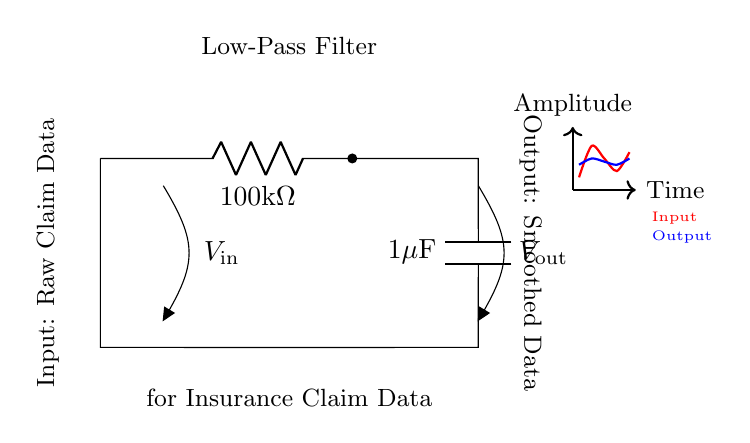What type of filter is represented in the circuit? The circuit is a low-pass filter, which allows low-frequency signals to pass while attenuating high-frequency signals.
Answer: low-pass filter What is the resistance value used in the circuit? The resistor shown in the circuit is labeled as 100 kilohms, representing its resistance value.
Answer: 100 kilohms What is the capacitance value in the filter? The capacitor in the circuit is labeled as 1 microfarad, which indicates its capacitance value.
Answer: 1 microfarad What does the output voltage represent in this circuit? The output voltage represents the smoothed data derived from the raw claim data input, which is affected by the low-pass filtering process.
Answer: Smoothed data How does the low-pass filter affect fluctuations in the input data? The low-pass filter attenuates rapid fluctuations in the input data, allowing only gradual changes to appear in the output, thereby smoothing the data trend.
Answer: Attenuates fluctuations What is the purpose of using a low-pass filter in insurance claim data analysis? The purpose is to reduce noise and smooth out data fluctuations, enabling better trend analysis and forecasting in claims data over time.
Answer: Smoothing data What is the significance of the input labeled "Raw Claim Data"? The significance lies in it being the unprocessed data that may contain high-frequency noise or fluctuations before filtering occurs.
Answer: Unprocessed data 